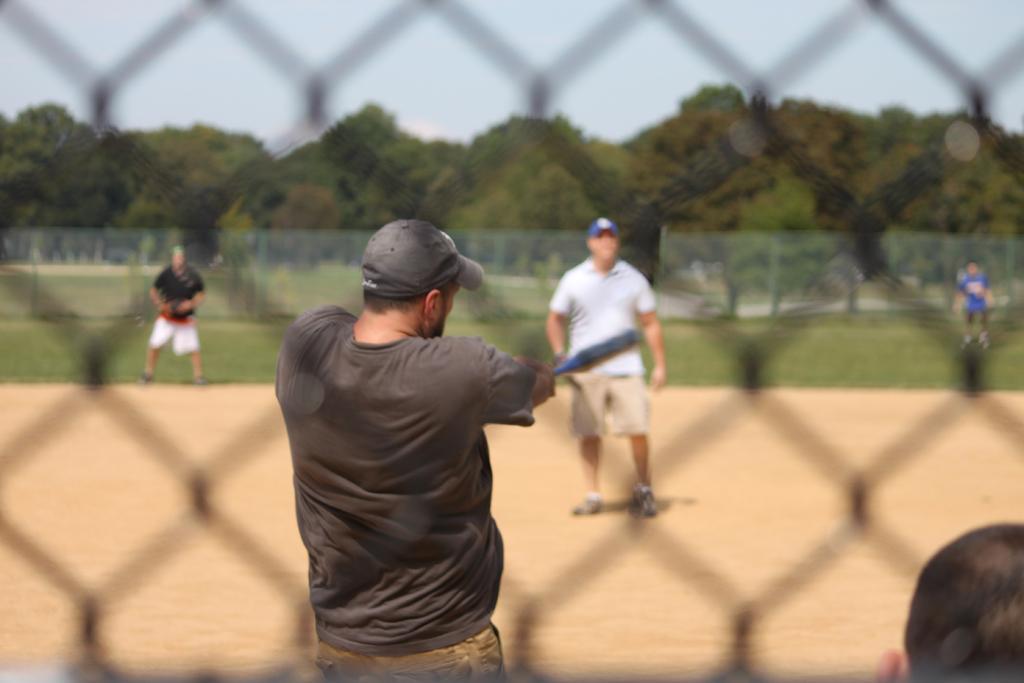Please provide a concise description of this image. In this image we can see the view of a playground, there is the sky towards the top of the image, there are trees, there is a fence, there are four men standing, there are two men wearing caps, there is a man holding an object, there is a person's head towards the bottom of the image. 